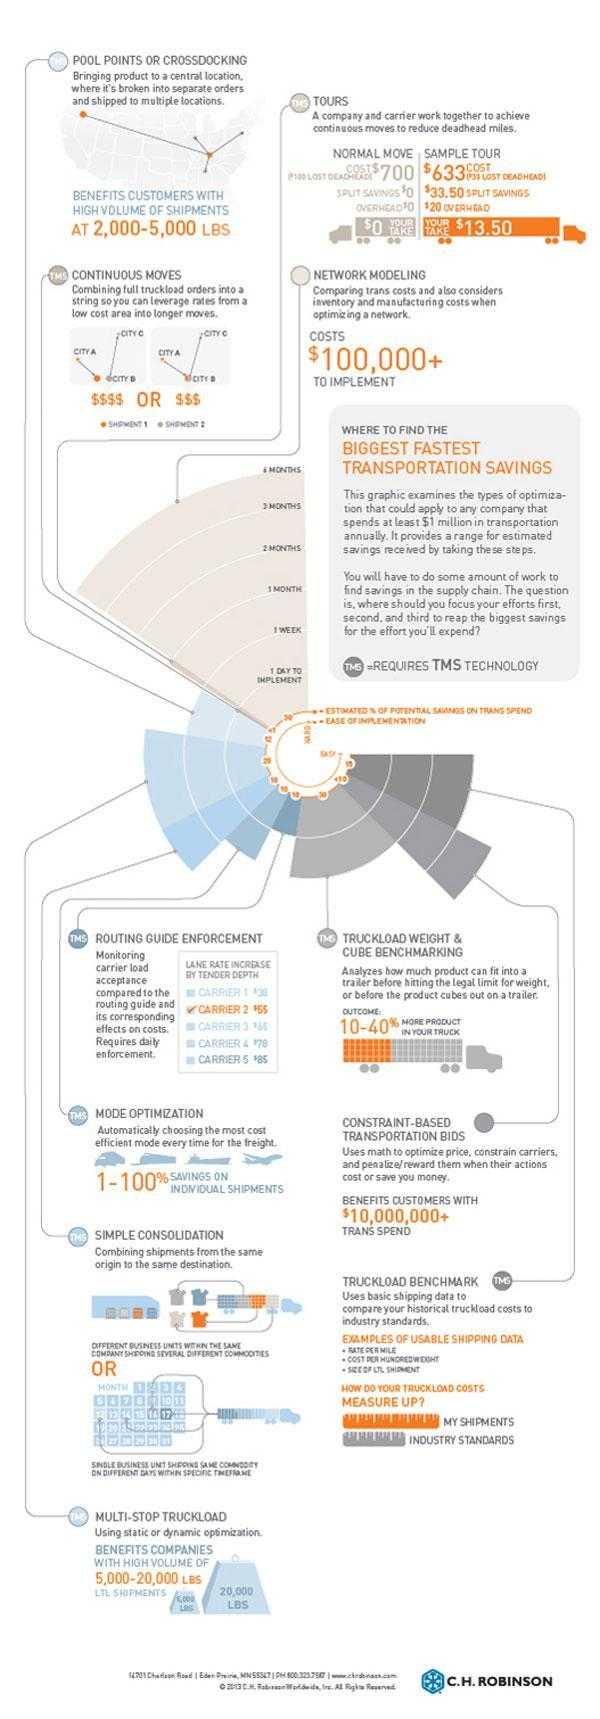How many transportation methods use the TMS technology?
Answer the question with a short phrase. 8 Which transportation method has the highest cost of implementation? Network Modeling Which method of shipping uses cities having lower cost to reduce shipping costs, Pool Points, Continuous Moves, or Cross Docking? Continuous Moves 